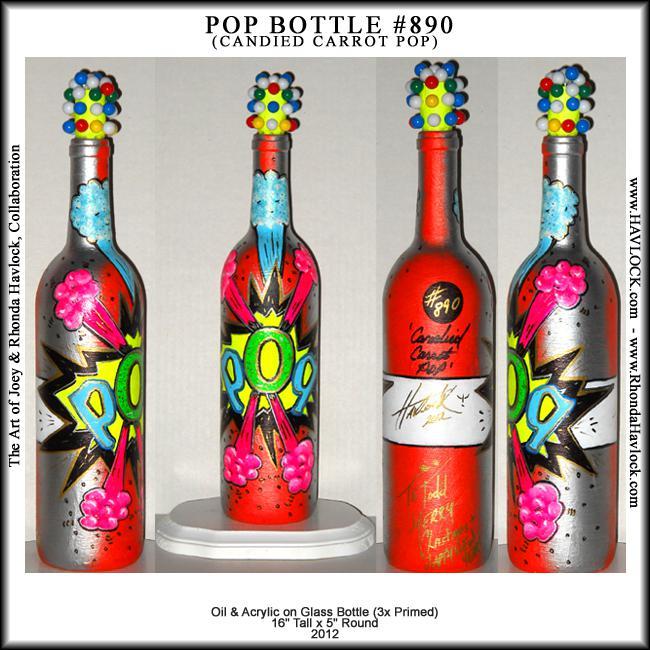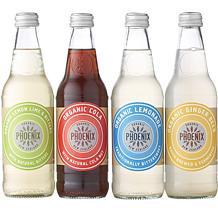The first image is the image on the left, the second image is the image on the right. Assess this claim about the two images: "One image contains exactly four bottles with various colored circle shapes on each label, and the other image contains no more than four bottles with colorful imagery on their labels.". Correct or not? Answer yes or no. Yes. The first image is the image on the left, the second image is the image on the right. Considering the images on both sides, is "There are more bottles in the image on the left." valid? Answer yes or no. No. 